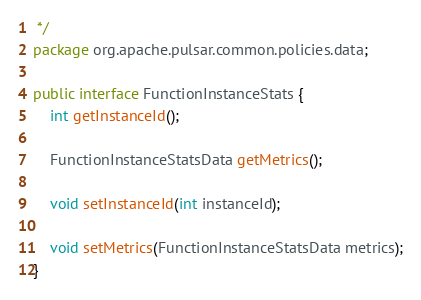Convert code to text. <code><loc_0><loc_0><loc_500><loc_500><_Java_> */
package org.apache.pulsar.common.policies.data;

public interface FunctionInstanceStats {
    int getInstanceId();

    FunctionInstanceStatsData getMetrics();

    void setInstanceId(int instanceId);

    void setMetrics(FunctionInstanceStatsData metrics);
}
</code> 